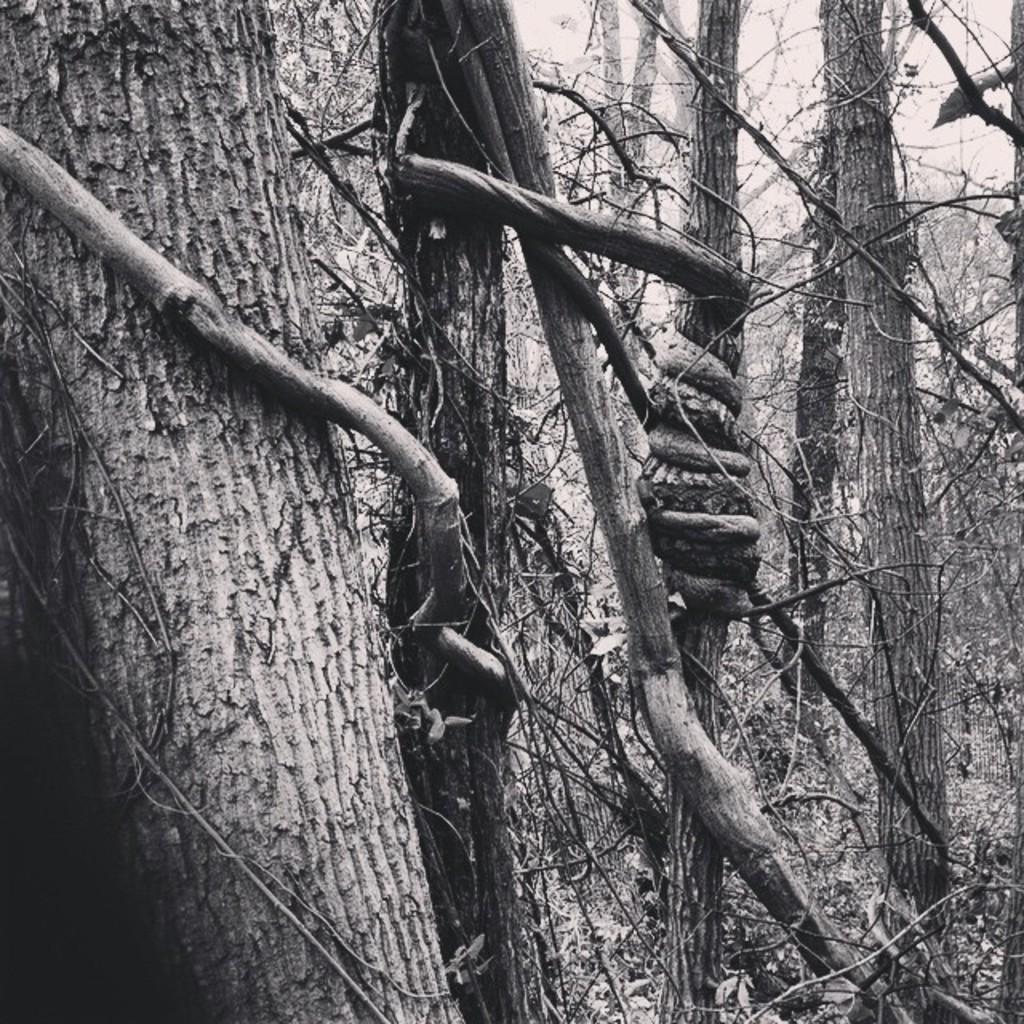What type of vegetation is present in the image? There are many trees in the image. What is visible at the top of the image? The sky is visible at the top of the image. How many wrist movements can be seen in the image? There are no wrist movements visible in the image, as it primarily features trees and the sky. 